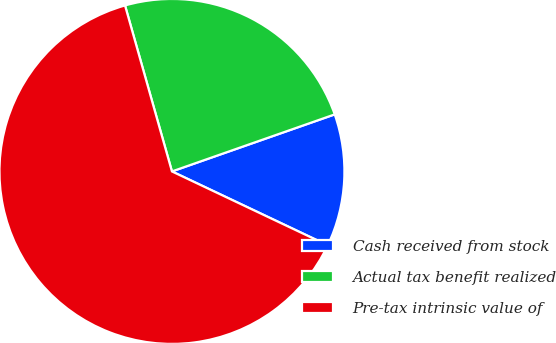Convert chart to OTSL. <chart><loc_0><loc_0><loc_500><loc_500><pie_chart><fcel>Cash received from stock<fcel>Actual tax benefit realized<fcel>Pre-tax intrinsic value of<nl><fcel>12.41%<fcel>24.02%<fcel>63.57%<nl></chart> 